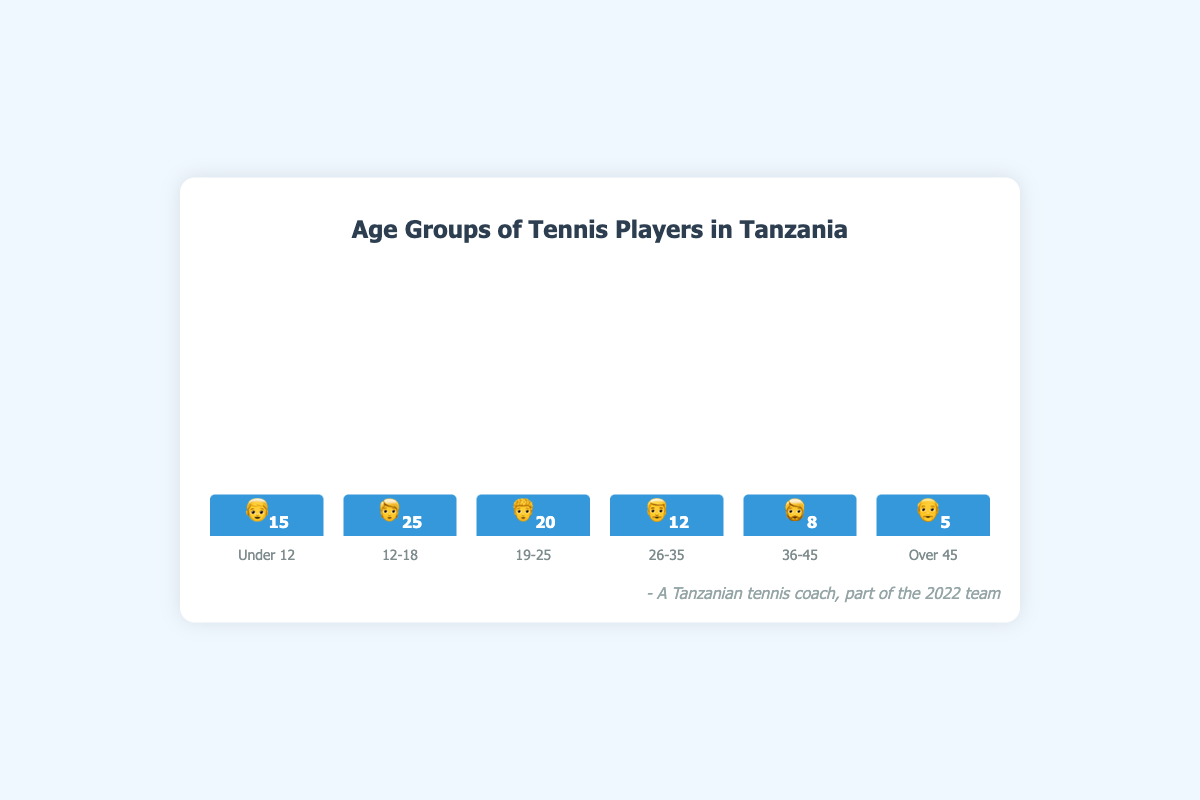What is the total number of tennis players under the age of 12? The number of players under the age of 12 can be found directly from the figure where it shows the count as 15 along with the emoji 👦.
Answer: 15 Which age group has the highest number of tennis players? By comparing the heights of the bars, the age group 12-18, represented by the tallest bar with the emoji 🧑 and count 25, has the highest number of players.
Answer: 12-18 How many more players are there in the 12-18 age group compared to the Over 45 age group? The 12-18 age group has 25 players, and the Over 45 age group has 5 players. The difference is 25 - 5.
Answer: 20 What is the combined count of players in the 26-35 and 36-45 age groups? The 26-35 age group has 12 players, and the 36-45 age group has 8 players. The combined count is 12 + 8.
Answer: 20 Which age groups have fewer than 10 players? The groups with counts fewer than 10 are easily identified as 36-45 with 8 players and Over 45 with 5 players.
Answer: 36-45, Over 45 What is the percentage of players in the 19-25 age group relative to the total number of players? The 19-25 age group has 20 players. The total number of players across all groups is 15 + 25 + 20 + 12 + 8 + 5 = 85. The percentage is (20/85) * 100.
Answer: 23.53% If the players under 12 were split into three equal teams, how many players would be in each team? With 15 players in the Under 12 group, splitting into 3 equal teams would result in 15 / 3.
Answer: 5 Which emoji represents the age group with the second-highest number of players? The second-highest number of players is found in the 19-25 age group, which has 20 players and is represented by the emoji 🧑‍🦱.
Answer: 🧑‍🦱 How many players are in the age group having the lowest bar height? The age group with the lowest bar height is the Over 45 group, with a count of 5 players, represented by the emoji 👴.
Answer: 5 Is the count of players in the 12-18 age group more than double that of the 26-35 age group? The 12-18 group has 25 players. The 26-35 group has 12 players. Double the count of 26-35 is 12 * 2 = 24. Since 25 is more than 24, the answer is yes.
Answer: Yes 